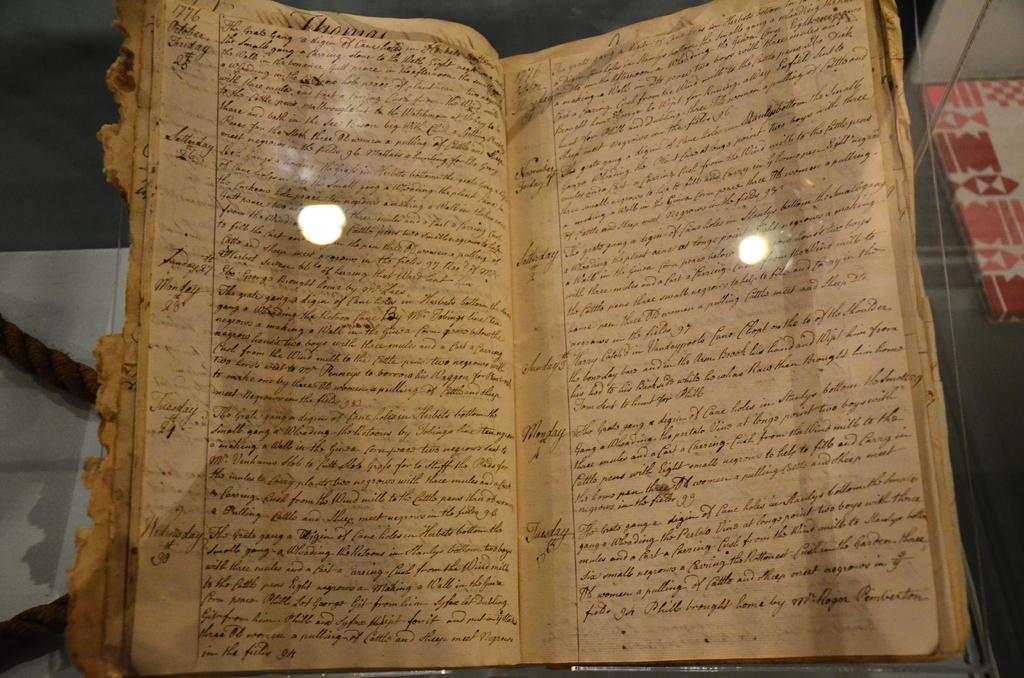<image>
Provide a brief description of the given image. A worn out log book showing the days Thursday, Friday, Saturday and so on. 